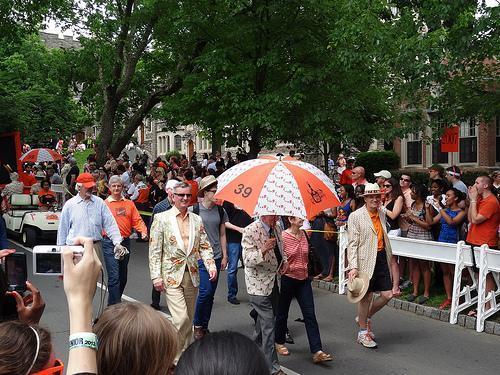How many umbrellas are in the scene?
Give a very brief answer. 2. 